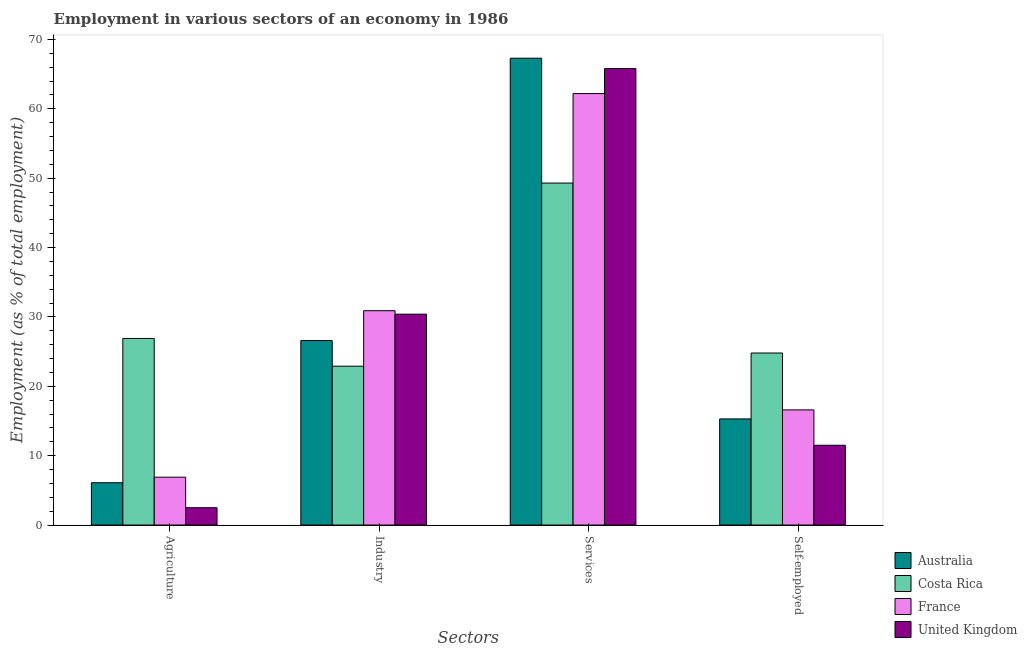How many groups of bars are there?
Give a very brief answer. 4. Are the number of bars on each tick of the X-axis equal?
Provide a short and direct response. Yes. How many bars are there on the 3rd tick from the left?
Your answer should be very brief. 4. What is the label of the 1st group of bars from the left?
Your response must be concise. Agriculture. What is the percentage of workers in agriculture in Australia?
Ensure brevity in your answer.  6.1. Across all countries, what is the maximum percentage of self employed workers?
Ensure brevity in your answer.  24.8. Across all countries, what is the minimum percentage of workers in services?
Give a very brief answer. 49.3. In which country was the percentage of workers in agriculture minimum?
Ensure brevity in your answer.  United Kingdom. What is the total percentage of self employed workers in the graph?
Offer a very short reply. 68.2. What is the difference between the percentage of workers in industry in United Kingdom and that in France?
Offer a terse response. -0.5. What is the difference between the percentage of workers in agriculture in France and the percentage of self employed workers in Costa Rica?
Offer a terse response. -17.9. What is the average percentage of workers in agriculture per country?
Make the answer very short. 10.6. What is the ratio of the percentage of workers in agriculture in Australia to that in France?
Offer a terse response. 0.88. Is the percentage of workers in industry in France less than that in Australia?
Offer a very short reply. No. Is the difference between the percentage of self employed workers in France and United Kingdom greater than the difference between the percentage of workers in industry in France and United Kingdom?
Make the answer very short. Yes. What is the difference between the highest and the second highest percentage of workers in industry?
Make the answer very short. 0.5. In how many countries, is the percentage of workers in services greater than the average percentage of workers in services taken over all countries?
Ensure brevity in your answer.  3. Is the sum of the percentage of workers in industry in France and United Kingdom greater than the maximum percentage of workers in agriculture across all countries?
Your answer should be very brief. Yes. What is the difference between two consecutive major ticks on the Y-axis?
Offer a terse response. 10. Are the values on the major ticks of Y-axis written in scientific E-notation?
Provide a short and direct response. No. Does the graph contain grids?
Ensure brevity in your answer.  No. How many legend labels are there?
Offer a very short reply. 4. How are the legend labels stacked?
Ensure brevity in your answer.  Vertical. What is the title of the graph?
Provide a succinct answer. Employment in various sectors of an economy in 1986. What is the label or title of the X-axis?
Give a very brief answer. Sectors. What is the label or title of the Y-axis?
Keep it short and to the point. Employment (as % of total employment). What is the Employment (as % of total employment) in Australia in Agriculture?
Your response must be concise. 6.1. What is the Employment (as % of total employment) in Costa Rica in Agriculture?
Your response must be concise. 26.9. What is the Employment (as % of total employment) of France in Agriculture?
Ensure brevity in your answer.  6.9. What is the Employment (as % of total employment) in United Kingdom in Agriculture?
Give a very brief answer. 2.5. What is the Employment (as % of total employment) in Australia in Industry?
Provide a succinct answer. 26.6. What is the Employment (as % of total employment) of Costa Rica in Industry?
Provide a short and direct response. 22.9. What is the Employment (as % of total employment) in France in Industry?
Give a very brief answer. 30.9. What is the Employment (as % of total employment) of United Kingdom in Industry?
Keep it short and to the point. 30.4. What is the Employment (as % of total employment) in Australia in Services?
Your response must be concise. 67.3. What is the Employment (as % of total employment) in Costa Rica in Services?
Your response must be concise. 49.3. What is the Employment (as % of total employment) of France in Services?
Ensure brevity in your answer.  62.2. What is the Employment (as % of total employment) in United Kingdom in Services?
Offer a very short reply. 65.8. What is the Employment (as % of total employment) of Australia in Self-employed?
Provide a succinct answer. 15.3. What is the Employment (as % of total employment) of Costa Rica in Self-employed?
Give a very brief answer. 24.8. What is the Employment (as % of total employment) of France in Self-employed?
Offer a very short reply. 16.6. Across all Sectors, what is the maximum Employment (as % of total employment) in Australia?
Keep it short and to the point. 67.3. Across all Sectors, what is the maximum Employment (as % of total employment) in Costa Rica?
Your response must be concise. 49.3. Across all Sectors, what is the maximum Employment (as % of total employment) in France?
Your response must be concise. 62.2. Across all Sectors, what is the maximum Employment (as % of total employment) in United Kingdom?
Provide a short and direct response. 65.8. Across all Sectors, what is the minimum Employment (as % of total employment) of Australia?
Offer a terse response. 6.1. Across all Sectors, what is the minimum Employment (as % of total employment) of Costa Rica?
Your response must be concise. 22.9. Across all Sectors, what is the minimum Employment (as % of total employment) in France?
Provide a short and direct response. 6.9. What is the total Employment (as % of total employment) in Australia in the graph?
Give a very brief answer. 115.3. What is the total Employment (as % of total employment) of Costa Rica in the graph?
Offer a terse response. 123.9. What is the total Employment (as % of total employment) of France in the graph?
Provide a short and direct response. 116.6. What is the total Employment (as % of total employment) of United Kingdom in the graph?
Your answer should be very brief. 110.2. What is the difference between the Employment (as % of total employment) in Australia in Agriculture and that in Industry?
Make the answer very short. -20.5. What is the difference between the Employment (as % of total employment) of France in Agriculture and that in Industry?
Make the answer very short. -24. What is the difference between the Employment (as % of total employment) in United Kingdom in Agriculture and that in Industry?
Provide a short and direct response. -27.9. What is the difference between the Employment (as % of total employment) in Australia in Agriculture and that in Services?
Provide a succinct answer. -61.2. What is the difference between the Employment (as % of total employment) of Costa Rica in Agriculture and that in Services?
Provide a succinct answer. -22.4. What is the difference between the Employment (as % of total employment) in France in Agriculture and that in Services?
Provide a short and direct response. -55.3. What is the difference between the Employment (as % of total employment) of United Kingdom in Agriculture and that in Services?
Ensure brevity in your answer.  -63.3. What is the difference between the Employment (as % of total employment) of Australia in Agriculture and that in Self-employed?
Offer a very short reply. -9.2. What is the difference between the Employment (as % of total employment) of France in Agriculture and that in Self-employed?
Your response must be concise. -9.7. What is the difference between the Employment (as % of total employment) in Australia in Industry and that in Services?
Offer a very short reply. -40.7. What is the difference between the Employment (as % of total employment) in Costa Rica in Industry and that in Services?
Keep it short and to the point. -26.4. What is the difference between the Employment (as % of total employment) in France in Industry and that in Services?
Your answer should be compact. -31.3. What is the difference between the Employment (as % of total employment) of United Kingdom in Industry and that in Services?
Give a very brief answer. -35.4. What is the difference between the Employment (as % of total employment) of France in Industry and that in Self-employed?
Ensure brevity in your answer.  14.3. What is the difference between the Employment (as % of total employment) in United Kingdom in Industry and that in Self-employed?
Your answer should be very brief. 18.9. What is the difference between the Employment (as % of total employment) of France in Services and that in Self-employed?
Offer a terse response. 45.6. What is the difference between the Employment (as % of total employment) of United Kingdom in Services and that in Self-employed?
Your response must be concise. 54.3. What is the difference between the Employment (as % of total employment) in Australia in Agriculture and the Employment (as % of total employment) in Costa Rica in Industry?
Ensure brevity in your answer.  -16.8. What is the difference between the Employment (as % of total employment) of Australia in Agriculture and the Employment (as % of total employment) of France in Industry?
Your answer should be very brief. -24.8. What is the difference between the Employment (as % of total employment) in Australia in Agriculture and the Employment (as % of total employment) in United Kingdom in Industry?
Ensure brevity in your answer.  -24.3. What is the difference between the Employment (as % of total employment) in Costa Rica in Agriculture and the Employment (as % of total employment) in United Kingdom in Industry?
Make the answer very short. -3.5. What is the difference between the Employment (as % of total employment) of France in Agriculture and the Employment (as % of total employment) of United Kingdom in Industry?
Keep it short and to the point. -23.5. What is the difference between the Employment (as % of total employment) of Australia in Agriculture and the Employment (as % of total employment) of Costa Rica in Services?
Your response must be concise. -43.2. What is the difference between the Employment (as % of total employment) in Australia in Agriculture and the Employment (as % of total employment) in France in Services?
Your answer should be very brief. -56.1. What is the difference between the Employment (as % of total employment) of Australia in Agriculture and the Employment (as % of total employment) of United Kingdom in Services?
Offer a terse response. -59.7. What is the difference between the Employment (as % of total employment) in Costa Rica in Agriculture and the Employment (as % of total employment) in France in Services?
Your answer should be compact. -35.3. What is the difference between the Employment (as % of total employment) in Costa Rica in Agriculture and the Employment (as % of total employment) in United Kingdom in Services?
Offer a very short reply. -38.9. What is the difference between the Employment (as % of total employment) of France in Agriculture and the Employment (as % of total employment) of United Kingdom in Services?
Make the answer very short. -58.9. What is the difference between the Employment (as % of total employment) of Australia in Agriculture and the Employment (as % of total employment) of Costa Rica in Self-employed?
Offer a terse response. -18.7. What is the difference between the Employment (as % of total employment) of Australia in Agriculture and the Employment (as % of total employment) of United Kingdom in Self-employed?
Provide a short and direct response. -5.4. What is the difference between the Employment (as % of total employment) in Australia in Industry and the Employment (as % of total employment) in Costa Rica in Services?
Give a very brief answer. -22.7. What is the difference between the Employment (as % of total employment) of Australia in Industry and the Employment (as % of total employment) of France in Services?
Your response must be concise. -35.6. What is the difference between the Employment (as % of total employment) of Australia in Industry and the Employment (as % of total employment) of United Kingdom in Services?
Ensure brevity in your answer.  -39.2. What is the difference between the Employment (as % of total employment) in Costa Rica in Industry and the Employment (as % of total employment) in France in Services?
Provide a short and direct response. -39.3. What is the difference between the Employment (as % of total employment) of Costa Rica in Industry and the Employment (as % of total employment) of United Kingdom in Services?
Offer a very short reply. -42.9. What is the difference between the Employment (as % of total employment) in France in Industry and the Employment (as % of total employment) in United Kingdom in Services?
Offer a terse response. -34.9. What is the difference between the Employment (as % of total employment) of Australia in Industry and the Employment (as % of total employment) of Costa Rica in Self-employed?
Ensure brevity in your answer.  1.8. What is the difference between the Employment (as % of total employment) in Australia in Industry and the Employment (as % of total employment) in France in Self-employed?
Offer a very short reply. 10. What is the difference between the Employment (as % of total employment) of Australia in Industry and the Employment (as % of total employment) of United Kingdom in Self-employed?
Your response must be concise. 15.1. What is the difference between the Employment (as % of total employment) in Costa Rica in Industry and the Employment (as % of total employment) in France in Self-employed?
Your response must be concise. 6.3. What is the difference between the Employment (as % of total employment) of France in Industry and the Employment (as % of total employment) of United Kingdom in Self-employed?
Provide a succinct answer. 19.4. What is the difference between the Employment (as % of total employment) of Australia in Services and the Employment (as % of total employment) of Costa Rica in Self-employed?
Your response must be concise. 42.5. What is the difference between the Employment (as % of total employment) of Australia in Services and the Employment (as % of total employment) of France in Self-employed?
Offer a terse response. 50.7. What is the difference between the Employment (as % of total employment) of Australia in Services and the Employment (as % of total employment) of United Kingdom in Self-employed?
Your answer should be compact. 55.8. What is the difference between the Employment (as % of total employment) in Costa Rica in Services and the Employment (as % of total employment) in France in Self-employed?
Make the answer very short. 32.7. What is the difference between the Employment (as % of total employment) in Costa Rica in Services and the Employment (as % of total employment) in United Kingdom in Self-employed?
Your response must be concise. 37.8. What is the difference between the Employment (as % of total employment) in France in Services and the Employment (as % of total employment) in United Kingdom in Self-employed?
Offer a very short reply. 50.7. What is the average Employment (as % of total employment) of Australia per Sectors?
Ensure brevity in your answer.  28.82. What is the average Employment (as % of total employment) in Costa Rica per Sectors?
Your response must be concise. 30.98. What is the average Employment (as % of total employment) in France per Sectors?
Keep it short and to the point. 29.15. What is the average Employment (as % of total employment) in United Kingdom per Sectors?
Your answer should be compact. 27.55. What is the difference between the Employment (as % of total employment) of Australia and Employment (as % of total employment) of Costa Rica in Agriculture?
Provide a short and direct response. -20.8. What is the difference between the Employment (as % of total employment) of Australia and Employment (as % of total employment) of United Kingdom in Agriculture?
Offer a terse response. 3.6. What is the difference between the Employment (as % of total employment) of Costa Rica and Employment (as % of total employment) of France in Agriculture?
Provide a short and direct response. 20. What is the difference between the Employment (as % of total employment) in Costa Rica and Employment (as % of total employment) in United Kingdom in Agriculture?
Keep it short and to the point. 24.4. What is the difference between the Employment (as % of total employment) in Australia and Employment (as % of total employment) in United Kingdom in Industry?
Your response must be concise. -3.8. What is the difference between the Employment (as % of total employment) of Costa Rica and Employment (as % of total employment) of United Kingdom in Industry?
Give a very brief answer. -7.5. What is the difference between the Employment (as % of total employment) in Australia and Employment (as % of total employment) in France in Services?
Ensure brevity in your answer.  5.1. What is the difference between the Employment (as % of total employment) in Australia and Employment (as % of total employment) in United Kingdom in Services?
Offer a very short reply. 1.5. What is the difference between the Employment (as % of total employment) in Costa Rica and Employment (as % of total employment) in France in Services?
Make the answer very short. -12.9. What is the difference between the Employment (as % of total employment) of Costa Rica and Employment (as % of total employment) of United Kingdom in Services?
Give a very brief answer. -16.5. What is the difference between the Employment (as % of total employment) of Australia and Employment (as % of total employment) of Costa Rica in Self-employed?
Give a very brief answer. -9.5. What is the difference between the Employment (as % of total employment) in Australia and Employment (as % of total employment) in France in Self-employed?
Provide a short and direct response. -1.3. What is the difference between the Employment (as % of total employment) in Australia and Employment (as % of total employment) in United Kingdom in Self-employed?
Your answer should be compact. 3.8. What is the difference between the Employment (as % of total employment) of France and Employment (as % of total employment) of United Kingdom in Self-employed?
Your answer should be very brief. 5.1. What is the ratio of the Employment (as % of total employment) in Australia in Agriculture to that in Industry?
Offer a terse response. 0.23. What is the ratio of the Employment (as % of total employment) of Costa Rica in Agriculture to that in Industry?
Offer a terse response. 1.17. What is the ratio of the Employment (as % of total employment) in France in Agriculture to that in Industry?
Your answer should be very brief. 0.22. What is the ratio of the Employment (as % of total employment) of United Kingdom in Agriculture to that in Industry?
Offer a very short reply. 0.08. What is the ratio of the Employment (as % of total employment) of Australia in Agriculture to that in Services?
Your answer should be compact. 0.09. What is the ratio of the Employment (as % of total employment) in Costa Rica in Agriculture to that in Services?
Your answer should be very brief. 0.55. What is the ratio of the Employment (as % of total employment) of France in Agriculture to that in Services?
Ensure brevity in your answer.  0.11. What is the ratio of the Employment (as % of total employment) in United Kingdom in Agriculture to that in Services?
Give a very brief answer. 0.04. What is the ratio of the Employment (as % of total employment) in Australia in Agriculture to that in Self-employed?
Ensure brevity in your answer.  0.4. What is the ratio of the Employment (as % of total employment) in Costa Rica in Agriculture to that in Self-employed?
Provide a short and direct response. 1.08. What is the ratio of the Employment (as % of total employment) of France in Agriculture to that in Self-employed?
Offer a terse response. 0.42. What is the ratio of the Employment (as % of total employment) in United Kingdom in Agriculture to that in Self-employed?
Provide a succinct answer. 0.22. What is the ratio of the Employment (as % of total employment) of Australia in Industry to that in Services?
Provide a short and direct response. 0.4. What is the ratio of the Employment (as % of total employment) of Costa Rica in Industry to that in Services?
Your response must be concise. 0.46. What is the ratio of the Employment (as % of total employment) in France in Industry to that in Services?
Make the answer very short. 0.5. What is the ratio of the Employment (as % of total employment) in United Kingdom in Industry to that in Services?
Provide a short and direct response. 0.46. What is the ratio of the Employment (as % of total employment) in Australia in Industry to that in Self-employed?
Keep it short and to the point. 1.74. What is the ratio of the Employment (as % of total employment) of Costa Rica in Industry to that in Self-employed?
Your answer should be compact. 0.92. What is the ratio of the Employment (as % of total employment) of France in Industry to that in Self-employed?
Provide a short and direct response. 1.86. What is the ratio of the Employment (as % of total employment) in United Kingdom in Industry to that in Self-employed?
Offer a terse response. 2.64. What is the ratio of the Employment (as % of total employment) of Australia in Services to that in Self-employed?
Give a very brief answer. 4.4. What is the ratio of the Employment (as % of total employment) in Costa Rica in Services to that in Self-employed?
Your answer should be very brief. 1.99. What is the ratio of the Employment (as % of total employment) of France in Services to that in Self-employed?
Provide a succinct answer. 3.75. What is the ratio of the Employment (as % of total employment) of United Kingdom in Services to that in Self-employed?
Offer a very short reply. 5.72. What is the difference between the highest and the second highest Employment (as % of total employment) in Australia?
Give a very brief answer. 40.7. What is the difference between the highest and the second highest Employment (as % of total employment) in Costa Rica?
Provide a succinct answer. 22.4. What is the difference between the highest and the second highest Employment (as % of total employment) in France?
Give a very brief answer. 31.3. What is the difference between the highest and the second highest Employment (as % of total employment) of United Kingdom?
Your answer should be compact. 35.4. What is the difference between the highest and the lowest Employment (as % of total employment) in Australia?
Your answer should be compact. 61.2. What is the difference between the highest and the lowest Employment (as % of total employment) of Costa Rica?
Provide a short and direct response. 26.4. What is the difference between the highest and the lowest Employment (as % of total employment) in France?
Your answer should be very brief. 55.3. What is the difference between the highest and the lowest Employment (as % of total employment) of United Kingdom?
Your response must be concise. 63.3. 